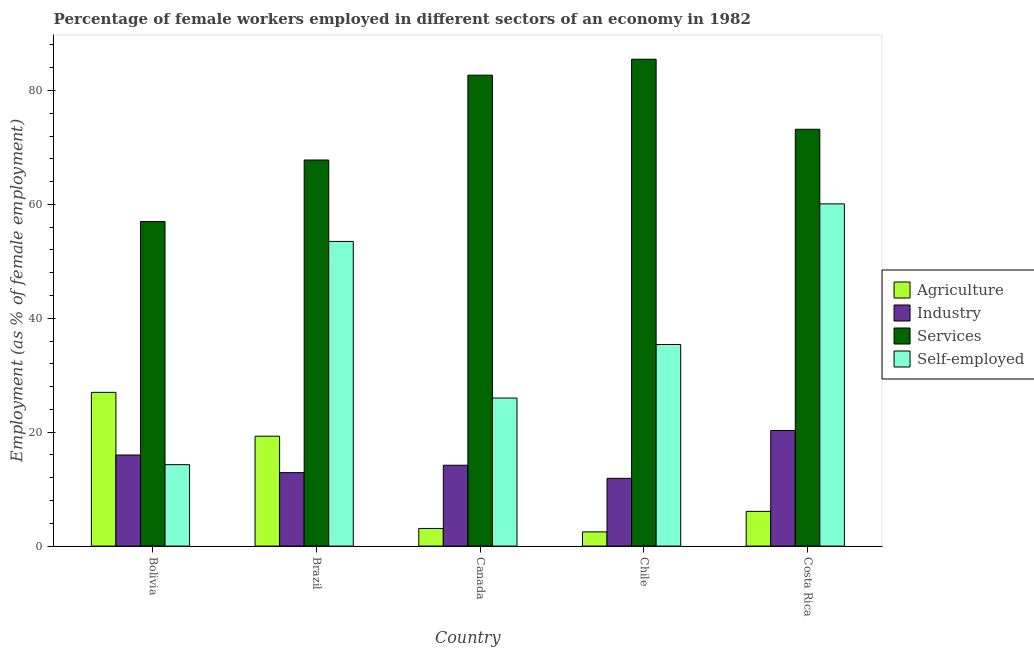How many different coloured bars are there?
Provide a short and direct response. 4. Are the number of bars per tick equal to the number of legend labels?
Your answer should be very brief. Yes. How many bars are there on the 5th tick from the right?
Your response must be concise. 4. In how many cases, is the number of bars for a given country not equal to the number of legend labels?
Your response must be concise. 0. What is the percentage of female workers in industry in Chile?
Your response must be concise. 11.9. Across all countries, what is the minimum percentage of female workers in industry?
Your answer should be compact. 11.9. In which country was the percentage of female workers in agriculture minimum?
Provide a short and direct response. Chile. What is the total percentage of female workers in services in the graph?
Keep it short and to the point. 366.2. What is the difference between the percentage of female workers in agriculture in Bolivia and that in Chile?
Provide a short and direct response. 24.5. What is the difference between the percentage of female workers in industry in Canada and the percentage of female workers in services in Brazil?
Your response must be concise. -53.6. What is the average percentage of female workers in services per country?
Offer a terse response. 73.24. What is the difference between the percentage of self employed female workers and percentage of female workers in services in Bolivia?
Ensure brevity in your answer.  -42.7. In how many countries, is the percentage of female workers in services greater than 24 %?
Keep it short and to the point. 5. What is the ratio of the percentage of female workers in agriculture in Brazil to that in Costa Rica?
Offer a terse response. 3.16. Is the percentage of female workers in agriculture in Bolivia less than that in Brazil?
Keep it short and to the point. No. Is the difference between the percentage of self employed female workers in Brazil and Canada greater than the difference between the percentage of female workers in agriculture in Brazil and Canada?
Keep it short and to the point. Yes. What is the difference between the highest and the second highest percentage of female workers in services?
Provide a succinct answer. 2.8. What is the difference between the highest and the lowest percentage of female workers in agriculture?
Make the answer very short. 24.5. Is it the case that in every country, the sum of the percentage of female workers in services and percentage of female workers in agriculture is greater than the sum of percentage of self employed female workers and percentage of female workers in industry?
Provide a succinct answer. Yes. What does the 4th bar from the left in Canada represents?
Provide a succinct answer. Self-employed. What does the 1st bar from the right in Bolivia represents?
Offer a terse response. Self-employed. How many bars are there?
Provide a short and direct response. 20. How many countries are there in the graph?
Your response must be concise. 5. What is the difference between two consecutive major ticks on the Y-axis?
Make the answer very short. 20. Are the values on the major ticks of Y-axis written in scientific E-notation?
Make the answer very short. No. Does the graph contain any zero values?
Keep it short and to the point. No. Does the graph contain grids?
Ensure brevity in your answer.  No. How many legend labels are there?
Give a very brief answer. 4. How are the legend labels stacked?
Provide a succinct answer. Vertical. What is the title of the graph?
Keep it short and to the point. Percentage of female workers employed in different sectors of an economy in 1982. Does "Financial sector" appear as one of the legend labels in the graph?
Offer a very short reply. No. What is the label or title of the X-axis?
Ensure brevity in your answer.  Country. What is the label or title of the Y-axis?
Keep it short and to the point. Employment (as % of female employment). What is the Employment (as % of female employment) in Industry in Bolivia?
Provide a short and direct response. 16. What is the Employment (as % of female employment) of Self-employed in Bolivia?
Offer a terse response. 14.3. What is the Employment (as % of female employment) in Agriculture in Brazil?
Provide a short and direct response. 19.3. What is the Employment (as % of female employment) of Industry in Brazil?
Keep it short and to the point. 12.9. What is the Employment (as % of female employment) of Services in Brazil?
Your answer should be very brief. 67.8. What is the Employment (as % of female employment) of Self-employed in Brazil?
Keep it short and to the point. 53.5. What is the Employment (as % of female employment) of Agriculture in Canada?
Your response must be concise. 3.1. What is the Employment (as % of female employment) of Industry in Canada?
Offer a very short reply. 14.2. What is the Employment (as % of female employment) in Services in Canada?
Provide a short and direct response. 82.7. What is the Employment (as % of female employment) in Self-employed in Canada?
Provide a succinct answer. 26. What is the Employment (as % of female employment) in Industry in Chile?
Offer a very short reply. 11.9. What is the Employment (as % of female employment) in Services in Chile?
Your response must be concise. 85.5. What is the Employment (as % of female employment) in Self-employed in Chile?
Keep it short and to the point. 35.4. What is the Employment (as % of female employment) of Agriculture in Costa Rica?
Keep it short and to the point. 6.1. What is the Employment (as % of female employment) in Industry in Costa Rica?
Make the answer very short. 20.3. What is the Employment (as % of female employment) of Services in Costa Rica?
Offer a terse response. 73.2. What is the Employment (as % of female employment) in Self-employed in Costa Rica?
Offer a terse response. 60.1. Across all countries, what is the maximum Employment (as % of female employment) of Industry?
Make the answer very short. 20.3. Across all countries, what is the maximum Employment (as % of female employment) in Services?
Offer a terse response. 85.5. Across all countries, what is the maximum Employment (as % of female employment) of Self-employed?
Your answer should be very brief. 60.1. Across all countries, what is the minimum Employment (as % of female employment) in Industry?
Your answer should be very brief. 11.9. Across all countries, what is the minimum Employment (as % of female employment) of Self-employed?
Give a very brief answer. 14.3. What is the total Employment (as % of female employment) in Industry in the graph?
Offer a terse response. 75.3. What is the total Employment (as % of female employment) of Services in the graph?
Offer a very short reply. 366.2. What is the total Employment (as % of female employment) of Self-employed in the graph?
Ensure brevity in your answer.  189.3. What is the difference between the Employment (as % of female employment) of Services in Bolivia and that in Brazil?
Offer a very short reply. -10.8. What is the difference between the Employment (as % of female employment) in Self-employed in Bolivia and that in Brazil?
Offer a terse response. -39.2. What is the difference between the Employment (as % of female employment) of Agriculture in Bolivia and that in Canada?
Your response must be concise. 23.9. What is the difference between the Employment (as % of female employment) of Services in Bolivia and that in Canada?
Ensure brevity in your answer.  -25.7. What is the difference between the Employment (as % of female employment) in Services in Bolivia and that in Chile?
Your answer should be compact. -28.5. What is the difference between the Employment (as % of female employment) in Self-employed in Bolivia and that in Chile?
Your response must be concise. -21.1. What is the difference between the Employment (as % of female employment) of Agriculture in Bolivia and that in Costa Rica?
Provide a succinct answer. 20.9. What is the difference between the Employment (as % of female employment) of Industry in Bolivia and that in Costa Rica?
Provide a short and direct response. -4.3. What is the difference between the Employment (as % of female employment) of Services in Bolivia and that in Costa Rica?
Your answer should be compact. -16.2. What is the difference between the Employment (as % of female employment) in Self-employed in Bolivia and that in Costa Rica?
Provide a succinct answer. -45.8. What is the difference between the Employment (as % of female employment) of Agriculture in Brazil and that in Canada?
Provide a short and direct response. 16.2. What is the difference between the Employment (as % of female employment) of Services in Brazil and that in Canada?
Keep it short and to the point. -14.9. What is the difference between the Employment (as % of female employment) in Self-employed in Brazil and that in Canada?
Ensure brevity in your answer.  27.5. What is the difference between the Employment (as % of female employment) of Agriculture in Brazil and that in Chile?
Make the answer very short. 16.8. What is the difference between the Employment (as % of female employment) in Services in Brazil and that in Chile?
Your answer should be very brief. -17.7. What is the difference between the Employment (as % of female employment) of Agriculture in Brazil and that in Costa Rica?
Give a very brief answer. 13.2. What is the difference between the Employment (as % of female employment) in Services in Brazil and that in Costa Rica?
Your answer should be very brief. -5.4. What is the difference between the Employment (as % of female employment) in Agriculture in Canada and that in Chile?
Provide a succinct answer. 0.6. What is the difference between the Employment (as % of female employment) in Industry in Canada and that in Chile?
Provide a succinct answer. 2.3. What is the difference between the Employment (as % of female employment) in Self-employed in Canada and that in Chile?
Give a very brief answer. -9.4. What is the difference between the Employment (as % of female employment) of Services in Canada and that in Costa Rica?
Your answer should be compact. 9.5. What is the difference between the Employment (as % of female employment) of Self-employed in Canada and that in Costa Rica?
Your response must be concise. -34.1. What is the difference between the Employment (as % of female employment) in Agriculture in Chile and that in Costa Rica?
Provide a succinct answer. -3.6. What is the difference between the Employment (as % of female employment) of Services in Chile and that in Costa Rica?
Your response must be concise. 12.3. What is the difference between the Employment (as % of female employment) in Self-employed in Chile and that in Costa Rica?
Your answer should be very brief. -24.7. What is the difference between the Employment (as % of female employment) of Agriculture in Bolivia and the Employment (as % of female employment) of Services in Brazil?
Make the answer very short. -40.8. What is the difference between the Employment (as % of female employment) of Agriculture in Bolivia and the Employment (as % of female employment) of Self-employed in Brazil?
Your answer should be compact. -26.5. What is the difference between the Employment (as % of female employment) of Industry in Bolivia and the Employment (as % of female employment) of Services in Brazil?
Provide a short and direct response. -51.8. What is the difference between the Employment (as % of female employment) in Industry in Bolivia and the Employment (as % of female employment) in Self-employed in Brazil?
Your answer should be compact. -37.5. What is the difference between the Employment (as % of female employment) in Services in Bolivia and the Employment (as % of female employment) in Self-employed in Brazil?
Make the answer very short. 3.5. What is the difference between the Employment (as % of female employment) in Agriculture in Bolivia and the Employment (as % of female employment) in Industry in Canada?
Offer a terse response. 12.8. What is the difference between the Employment (as % of female employment) in Agriculture in Bolivia and the Employment (as % of female employment) in Services in Canada?
Give a very brief answer. -55.7. What is the difference between the Employment (as % of female employment) of Agriculture in Bolivia and the Employment (as % of female employment) of Self-employed in Canada?
Offer a terse response. 1. What is the difference between the Employment (as % of female employment) of Industry in Bolivia and the Employment (as % of female employment) of Services in Canada?
Offer a terse response. -66.7. What is the difference between the Employment (as % of female employment) of Industry in Bolivia and the Employment (as % of female employment) of Self-employed in Canada?
Provide a short and direct response. -10. What is the difference between the Employment (as % of female employment) of Agriculture in Bolivia and the Employment (as % of female employment) of Services in Chile?
Provide a succinct answer. -58.5. What is the difference between the Employment (as % of female employment) in Industry in Bolivia and the Employment (as % of female employment) in Services in Chile?
Offer a very short reply. -69.5. What is the difference between the Employment (as % of female employment) of Industry in Bolivia and the Employment (as % of female employment) of Self-employed in Chile?
Keep it short and to the point. -19.4. What is the difference between the Employment (as % of female employment) in Services in Bolivia and the Employment (as % of female employment) in Self-employed in Chile?
Your answer should be compact. 21.6. What is the difference between the Employment (as % of female employment) in Agriculture in Bolivia and the Employment (as % of female employment) in Industry in Costa Rica?
Your response must be concise. 6.7. What is the difference between the Employment (as % of female employment) of Agriculture in Bolivia and the Employment (as % of female employment) of Services in Costa Rica?
Your answer should be very brief. -46.2. What is the difference between the Employment (as % of female employment) of Agriculture in Bolivia and the Employment (as % of female employment) of Self-employed in Costa Rica?
Provide a succinct answer. -33.1. What is the difference between the Employment (as % of female employment) in Industry in Bolivia and the Employment (as % of female employment) in Services in Costa Rica?
Give a very brief answer. -57.2. What is the difference between the Employment (as % of female employment) of Industry in Bolivia and the Employment (as % of female employment) of Self-employed in Costa Rica?
Keep it short and to the point. -44.1. What is the difference between the Employment (as % of female employment) of Services in Bolivia and the Employment (as % of female employment) of Self-employed in Costa Rica?
Keep it short and to the point. -3.1. What is the difference between the Employment (as % of female employment) of Agriculture in Brazil and the Employment (as % of female employment) of Services in Canada?
Ensure brevity in your answer.  -63.4. What is the difference between the Employment (as % of female employment) in Industry in Brazil and the Employment (as % of female employment) in Services in Canada?
Keep it short and to the point. -69.8. What is the difference between the Employment (as % of female employment) in Industry in Brazil and the Employment (as % of female employment) in Self-employed in Canada?
Provide a short and direct response. -13.1. What is the difference between the Employment (as % of female employment) in Services in Brazil and the Employment (as % of female employment) in Self-employed in Canada?
Offer a very short reply. 41.8. What is the difference between the Employment (as % of female employment) of Agriculture in Brazil and the Employment (as % of female employment) of Services in Chile?
Your answer should be very brief. -66.2. What is the difference between the Employment (as % of female employment) of Agriculture in Brazil and the Employment (as % of female employment) of Self-employed in Chile?
Keep it short and to the point. -16.1. What is the difference between the Employment (as % of female employment) of Industry in Brazil and the Employment (as % of female employment) of Services in Chile?
Ensure brevity in your answer.  -72.6. What is the difference between the Employment (as % of female employment) of Industry in Brazil and the Employment (as % of female employment) of Self-employed in Chile?
Offer a terse response. -22.5. What is the difference between the Employment (as % of female employment) in Services in Brazil and the Employment (as % of female employment) in Self-employed in Chile?
Provide a short and direct response. 32.4. What is the difference between the Employment (as % of female employment) in Agriculture in Brazil and the Employment (as % of female employment) in Industry in Costa Rica?
Give a very brief answer. -1. What is the difference between the Employment (as % of female employment) in Agriculture in Brazil and the Employment (as % of female employment) in Services in Costa Rica?
Provide a short and direct response. -53.9. What is the difference between the Employment (as % of female employment) of Agriculture in Brazil and the Employment (as % of female employment) of Self-employed in Costa Rica?
Your response must be concise. -40.8. What is the difference between the Employment (as % of female employment) of Industry in Brazil and the Employment (as % of female employment) of Services in Costa Rica?
Your response must be concise. -60.3. What is the difference between the Employment (as % of female employment) in Industry in Brazil and the Employment (as % of female employment) in Self-employed in Costa Rica?
Offer a terse response. -47.2. What is the difference between the Employment (as % of female employment) of Services in Brazil and the Employment (as % of female employment) of Self-employed in Costa Rica?
Your answer should be very brief. 7.7. What is the difference between the Employment (as % of female employment) of Agriculture in Canada and the Employment (as % of female employment) of Industry in Chile?
Offer a very short reply. -8.8. What is the difference between the Employment (as % of female employment) of Agriculture in Canada and the Employment (as % of female employment) of Services in Chile?
Ensure brevity in your answer.  -82.4. What is the difference between the Employment (as % of female employment) in Agriculture in Canada and the Employment (as % of female employment) in Self-employed in Chile?
Your response must be concise. -32.3. What is the difference between the Employment (as % of female employment) of Industry in Canada and the Employment (as % of female employment) of Services in Chile?
Your answer should be compact. -71.3. What is the difference between the Employment (as % of female employment) in Industry in Canada and the Employment (as % of female employment) in Self-employed in Chile?
Offer a very short reply. -21.2. What is the difference between the Employment (as % of female employment) in Services in Canada and the Employment (as % of female employment) in Self-employed in Chile?
Give a very brief answer. 47.3. What is the difference between the Employment (as % of female employment) of Agriculture in Canada and the Employment (as % of female employment) of Industry in Costa Rica?
Offer a terse response. -17.2. What is the difference between the Employment (as % of female employment) in Agriculture in Canada and the Employment (as % of female employment) in Services in Costa Rica?
Your response must be concise. -70.1. What is the difference between the Employment (as % of female employment) in Agriculture in Canada and the Employment (as % of female employment) in Self-employed in Costa Rica?
Keep it short and to the point. -57. What is the difference between the Employment (as % of female employment) in Industry in Canada and the Employment (as % of female employment) in Services in Costa Rica?
Keep it short and to the point. -59. What is the difference between the Employment (as % of female employment) of Industry in Canada and the Employment (as % of female employment) of Self-employed in Costa Rica?
Your response must be concise. -45.9. What is the difference between the Employment (as % of female employment) of Services in Canada and the Employment (as % of female employment) of Self-employed in Costa Rica?
Your answer should be compact. 22.6. What is the difference between the Employment (as % of female employment) of Agriculture in Chile and the Employment (as % of female employment) of Industry in Costa Rica?
Your answer should be compact. -17.8. What is the difference between the Employment (as % of female employment) of Agriculture in Chile and the Employment (as % of female employment) of Services in Costa Rica?
Give a very brief answer. -70.7. What is the difference between the Employment (as % of female employment) in Agriculture in Chile and the Employment (as % of female employment) in Self-employed in Costa Rica?
Give a very brief answer. -57.6. What is the difference between the Employment (as % of female employment) of Industry in Chile and the Employment (as % of female employment) of Services in Costa Rica?
Give a very brief answer. -61.3. What is the difference between the Employment (as % of female employment) of Industry in Chile and the Employment (as % of female employment) of Self-employed in Costa Rica?
Give a very brief answer. -48.2. What is the difference between the Employment (as % of female employment) of Services in Chile and the Employment (as % of female employment) of Self-employed in Costa Rica?
Ensure brevity in your answer.  25.4. What is the average Employment (as % of female employment) of Industry per country?
Your answer should be compact. 15.06. What is the average Employment (as % of female employment) of Services per country?
Offer a terse response. 73.24. What is the average Employment (as % of female employment) of Self-employed per country?
Ensure brevity in your answer.  37.86. What is the difference between the Employment (as % of female employment) in Agriculture and Employment (as % of female employment) in Industry in Bolivia?
Your answer should be compact. 11. What is the difference between the Employment (as % of female employment) of Agriculture and Employment (as % of female employment) of Self-employed in Bolivia?
Provide a short and direct response. 12.7. What is the difference between the Employment (as % of female employment) in Industry and Employment (as % of female employment) in Services in Bolivia?
Ensure brevity in your answer.  -41. What is the difference between the Employment (as % of female employment) of Services and Employment (as % of female employment) of Self-employed in Bolivia?
Make the answer very short. 42.7. What is the difference between the Employment (as % of female employment) in Agriculture and Employment (as % of female employment) in Services in Brazil?
Offer a terse response. -48.5. What is the difference between the Employment (as % of female employment) of Agriculture and Employment (as % of female employment) of Self-employed in Brazil?
Make the answer very short. -34.2. What is the difference between the Employment (as % of female employment) in Industry and Employment (as % of female employment) in Services in Brazil?
Provide a short and direct response. -54.9. What is the difference between the Employment (as % of female employment) of Industry and Employment (as % of female employment) of Self-employed in Brazil?
Offer a terse response. -40.6. What is the difference between the Employment (as % of female employment) in Services and Employment (as % of female employment) in Self-employed in Brazil?
Provide a succinct answer. 14.3. What is the difference between the Employment (as % of female employment) of Agriculture and Employment (as % of female employment) of Services in Canada?
Provide a succinct answer. -79.6. What is the difference between the Employment (as % of female employment) of Agriculture and Employment (as % of female employment) of Self-employed in Canada?
Offer a very short reply. -22.9. What is the difference between the Employment (as % of female employment) in Industry and Employment (as % of female employment) in Services in Canada?
Make the answer very short. -68.5. What is the difference between the Employment (as % of female employment) of Services and Employment (as % of female employment) of Self-employed in Canada?
Make the answer very short. 56.7. What is the difference between the Employment (as % of female employment) of Agriculture and Employment (as % of female employment) of Industry in Chile?
Offer a very short reply. -9.4. What is the difference between the Employment (as % of female employment) of Agriculture and Employment (as % of female employment) of Services in Chile?
Provide a short and direct response. -83. What is the difference between the Employment (as % of female employment) of Agriculture and Employment (as % of female employment) of Self-employed in Chile?
Your answer should be compact. -32.9. What is the difference between the Employment (as % of female employment) of Industry and Employment (as % of female employment) of Services in Chile?
Give a very brief answer. -73.6. What is the difference between the Employment (as % of female employment) of Industry and Employment (as % of female employment) of Self-employed in Chile?
Ensure brevity in your answer.  -23.5. What is the difference between the Employment (as % of female employment) of Services and Employment (as % of female employment) of Self-employed in Chile?
Make the answer very short. 50.1. What is the difference between the Employment (as % of female employment) in Agriculture and Employment (as % of female employment) in Industry in Costa Rica?
Give a very brief answer. -14.2. What is the difference between the Employment (as % of female employment) of Agriculture and Employment (as % of female employment) of Services in Costa Rica?
Your answer should be compact. -67.1. What is the difference between the Employment (as % of female employment) in Agriculture and Employment (as % of female employment) in Self-employed in Costa Rica?
Your answer should be very brief. -54. What is the difference between the Employment (as % of female employment) of Industry and Employment (as % of female employment) of Services in Costa Rica?
Make the answer very short. -52.9. What is the difference between the Employment (as % of female employment) in Industry and Employment (as % of female employment) in Self-employed in Costa Rica?
Offer a terse response. -39.8. What is the ratio of the Employment (as % of female employment) of Agriculture in Bolivia to that in Brazil?
Provide a succinct answer. 1.4. What is the ratio of the Employment (as % of female employment) of Industry in Bolivia to that in Brazil?
Your response must be concise. 1.24. What is the ratio of the Employment (as % of female employment) in Services in Bolivia to that in Brazil?
Offer a very short reply. 0.84. What is the ratio of the Employment (as % of female employment) in Self-employed in Bolivia to that in Brazil?
Provide a succinct answer. 0.27. What is the ratio of the Employment (as % of female employment) in Agriculture in Bolivia to that in Canada?
Give a very brief answer. 8.71. What is the ratio of the Employment (as % of female employment) of Industry in Bolivia to that in Canada?
Provide a short and direct response. 1.13. What is the ratio of the Employment (as % of female employment) in Services in Bolivia to that in Canada?
Keep it short and to the point. 0.69. What is the ratio of the Employment (as % of female employment) of Self-employed in Bolivia to that in Canada?
Your answer should be very brief. 0.55. What is the ratio of the Employment (as % of female employment) of Industry in Bolivia to that in Chile?
Provide a succinct answer. 1.34. What is the ratio of the Employment (as % of female employment) in Self-employed in Bolivia to that in Chile?
Offer a very short reply. 0.4. What is the ratio of the Employment (as % of female employment) of Agriculture in Bolivia to that in Costa Rica?
Your response must be concise. 4.43. What is the ratio of the Employment (as % of female employment) in Industry in Bolivia to that in Costa Rica?
Make the answer very short. 0.79. What is the ratio of the Employment (as % of female employment) of Services in Bolivia to that in Costa Rica?
Give a very brief answer. 0.78. What is the ratio of the Employment (as % of female employment) in Self-employed in Bolivia to that in Costa Rica?
Make the answer very short. 0.24. What is the ratio of the Employment (as % of female employment) of Agriculture in Brazil to that in Canada?
Ensure brevity in your answer.  6.23. What is the ratio of the Employment (as % of female employment) of Industry in Brazil to that in Canada?
Make the answer very short. 0.91. What is the ratio of the Employment (as % of female employment) of Services in Brazil to that in Canada?
Keep it short and to the point. 0.82. What is the ratio of the Employment (as % of female employment) in Self-employed in Brazil to that in Canada?
Ensure brevity in your answer.  2.06. What is the ratio of the Employment (as % of female employment) of Agriculture in Brazil to that in Chile?
Ensure brevity in your answer.  7.72. What is the ratio of the Employment (as % of female employment) in Industry in Brazil to that in Chile?
Provide a succinct answer. 1.08. What is the ratio of the Employment (as % of female employment) in Services in Brazil to that in Chile?
Offer a terse response. 0.79. What is the ratio of the Employment (as % of female employment) of Self-employed in Brazil to that in Chile?
Keep it short and to the point. 1.51. What is the ratio of the Employment (as % of female employment) in Agriculture in Brazil to that in Costa Rica?
Offer a terse response. 3.16. What is the ratio of the Employment (as % of female employment) in Industry in Brazil to that in Costa Rica?
Your answer should be very brief. 0.64. What is the ratio of the Employment (as % of female employment) in Services in Brazil to that in Costa Rica?
Provide a short and direct response. 0.93. What is the ratio of the Employment (as % of female employment) of Self-employed in Brazil to that in Costa Rica?
Offer a terse response. 0.89. What is the ratio of the Employment (as % of female employment) in Agriculture in Canada to that in Chile?
Give a very brief answer. 1.24. What is the ratio of the Employment (as % of female employment) of Industry in Canada to that in Chile?
Keep it short and to the point. 1.19. What is the ratio of the Employment (as % of female employment) in Services in Canada to that in Chile?
Give a very brief answer. 0.97. What is the ratio of the Employment (as % of female employment) of Self-employed in Canada to that in Chile?
Your response must be concise. 0.73. What is the ratio of the Employment (as % of female employment) in Agriculture in Canada to that in Costa Rica?
Keep it short and to the point. 0.51. What is the ratio of the Employment (as % of female employment) of Industry in Canada to that in Costa Rica?
Your answer should be compact. 0.7. What is the ratio of the Employment (as % of female employment) in Services in Canada to that in Costa Rica?
Give a very brief answer. 1.13. What is the ratio of the Employment (as % of female employment) in Self-employed in Canada to that in Costa Rica?
Provide a succinct answer. 0.43. What is the ratio of the Employment (as % of female employment) in Agriculture in Chile to that in Costa Rica?
Ensure brevity in your answer.  0.41. What is the ratio of the Employment (as % of female employment) in Industry in Chile to that in Costa Rica?
Keep it short and to the point. 0.59. What is the ratio of the Employment (as % of female employment) of Services in Chile to that in Costa Rica?
Make the answer very short. 1.17. What is the ratio of the Employment (as % of female employment) of Self-employed in Chile to that in Costa Rica?
Ensure brevity in your answer.  0.59. What is the difference between the highest and the second highest Employment (as % of female employment) of Industry?
Offer a terse response. 4.3. What is the difference between the highest and the second highest Employment (as % of female employment) of Services?
Your answer should be very brief. 2.8. What is the difference between the highest and the lowest Employment (as % of female employment) of Agriculture?
Your response must be concise. 24.5. What is the difference between the highest and the lowest Employment (as % of female employment) in Self-employed?
Offer a terse response. 45.8. 